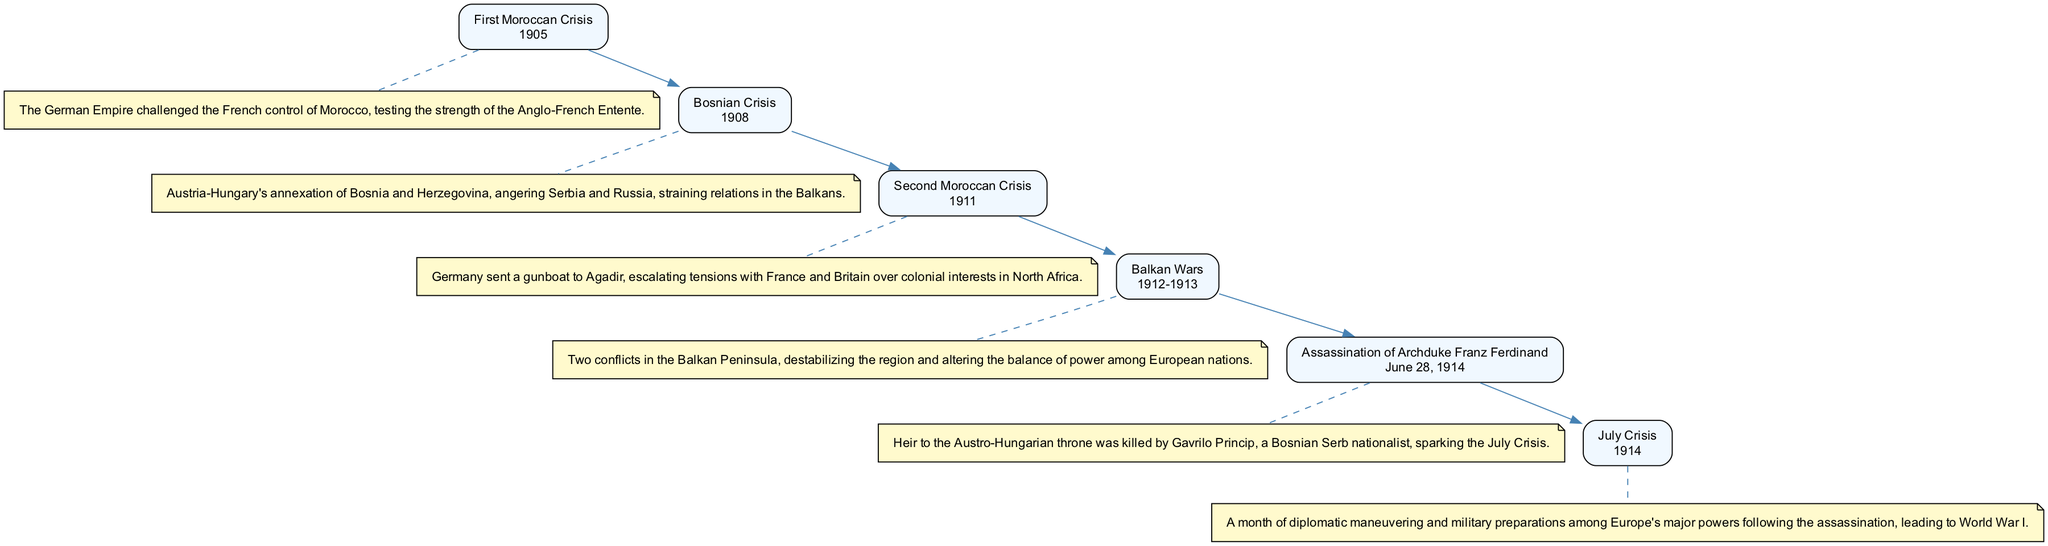What was the first crisis depicted in the diagram? The first event listed in the diagram is the First Moroccan Crisis, which is clearly mentioned at the top of the flow.
Answer: First Moroccan Crisis In which year did the Bosnian Crisis occur? The Bosnian Crisis is represented in the diagram with the year 1908 next to its title, making it easy to locate this information.
Answer: 1908 What event immediately followed the First Moroccan Crisis in chronological order? By tracing the flow of the diagram, the next event after the First Moroccan Crisis is the Bosnian Crisis, indicating the sequence of events leading up to World War I.
Answer: Bosnian Crisis How many crises are represented in the diagram before the assassination of Archduke Franz Ferdinand? There are five distinct events listed in the diagram that lead up to the assassination, which is the sixth event, indicating that five crises occurred prior.
Answer: 5 What significant event sparked the July Crisis? The diagram specifically indicates that the assassination of Archduke Franz Ferdinand is the event that instigated the July Crisis, linking these two events directly.
Answer: Assassination of Archduke Franz Ferdinand Which two events occurred in the year 1911? In the diagram, the Second Moroccan Crisis and the escalation of tensions are related to the same year, which is marked under the title of that event.
Answer: Second Moroccan Crisis What was the outcome of the July Crisis depicted in the diagram? The diagram indicates that the July Crisis led directly to World War I, establishing a clear causal relationship between these events.
Answer: World War I Which crisis involved Austria-Hungary's annexation of territories? In the diagram, the Bosnian Crisis is identified as the event that involved Austria-Hungary's annexation, which is highlighted in the description provided.
Answer: Bosnian Crisis What was the time span of the Balkan Wars represented in the diagram? The diagram shows that the Balkan Wars occurred between the years 1912 and 1913, hence indicating a two-year duration.
Answer: 1912-1913 